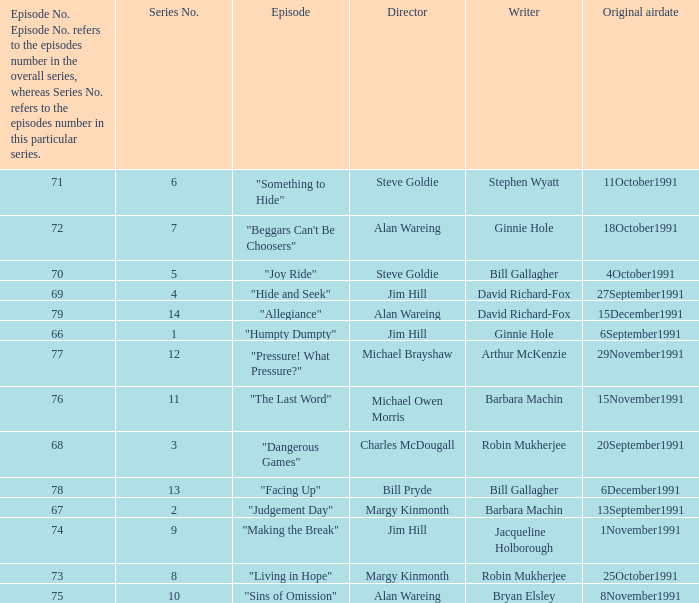Name the least series number for episode number being 78 13.0. 